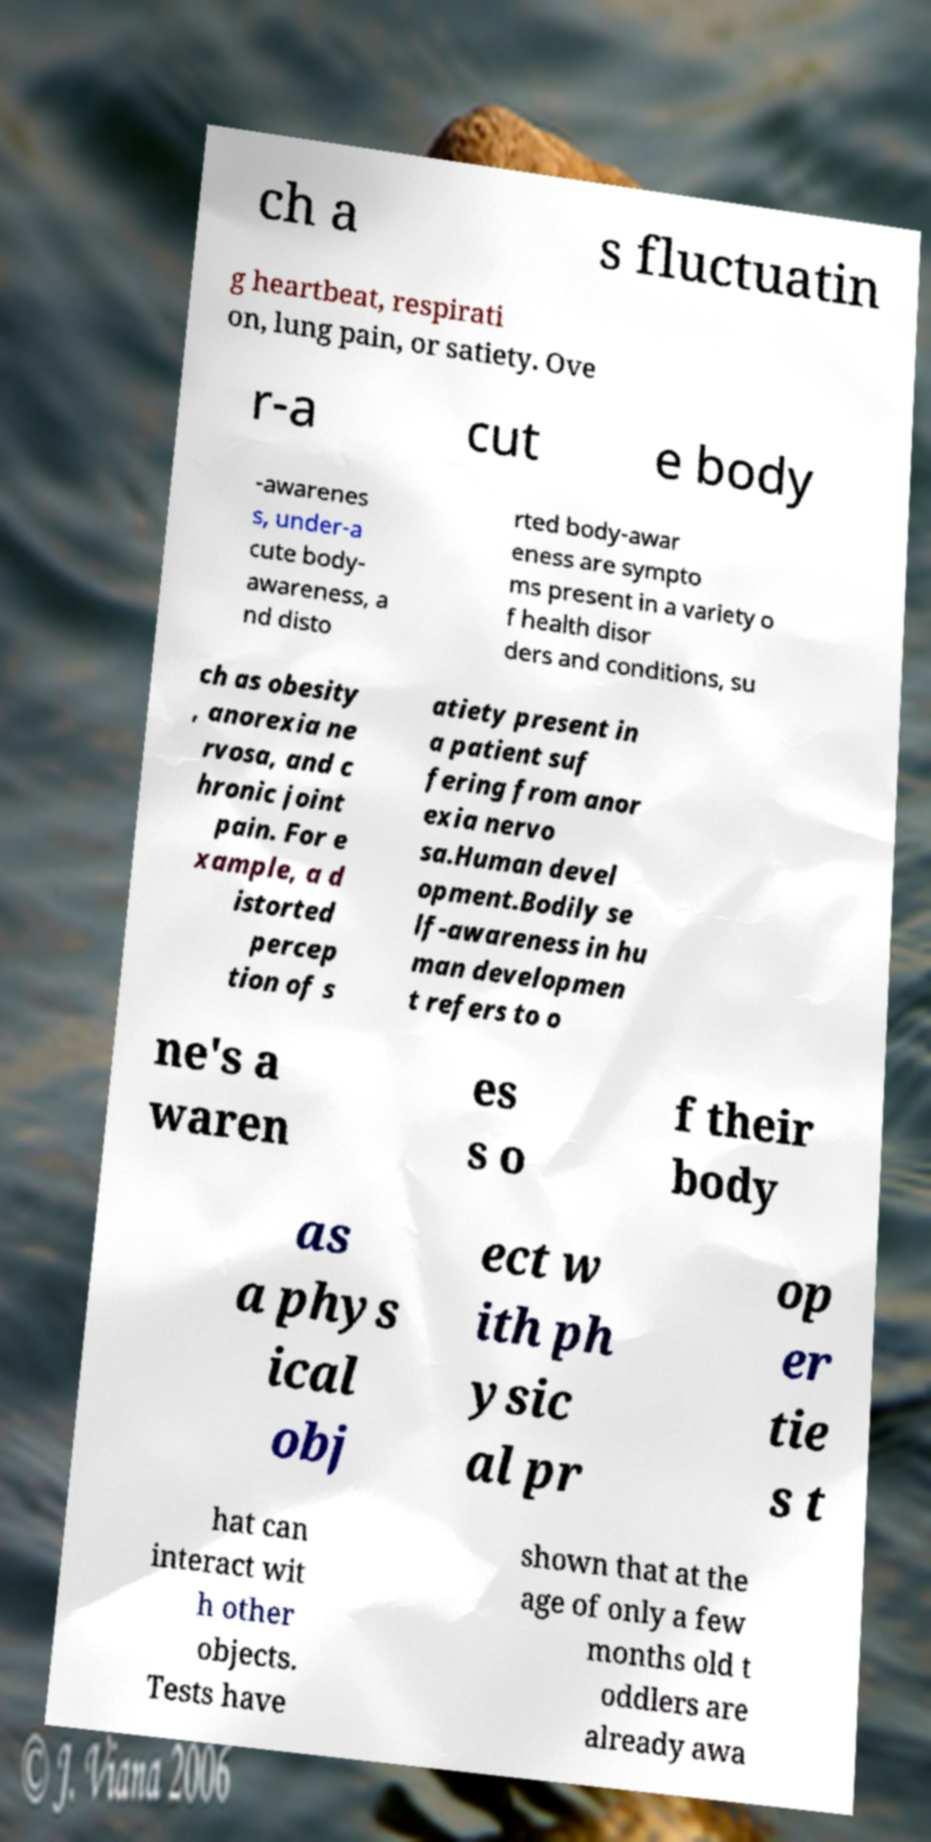What messages or text are displayed in this image? I need them in a readable, typed format. ch a s fluctuatin g heartbeat, respirati on, lung pain, or satiety. Ove r-a cut e body -awarenes s, under-a cute body- awareness, a nd disto rted body-awar eness are sympto ms present in a variety o f health disor ders and conditions, su ch as obesity , anorexia ne rvosa, and c hronic joint pain. For e xample, a d istorted percep tion of s atiety present in a patient suf fering from anor exia nervo sa.Human devel opment.Bodily se lf-awareness in hu man developmen t refers to o ne's a waren es s o f their body as a phys ical obj ect w ith ph ysic al pr op er tie s t hat can interact wit h other objects. Tests have shown that at the age of only a few months old t oddlers are already awa 